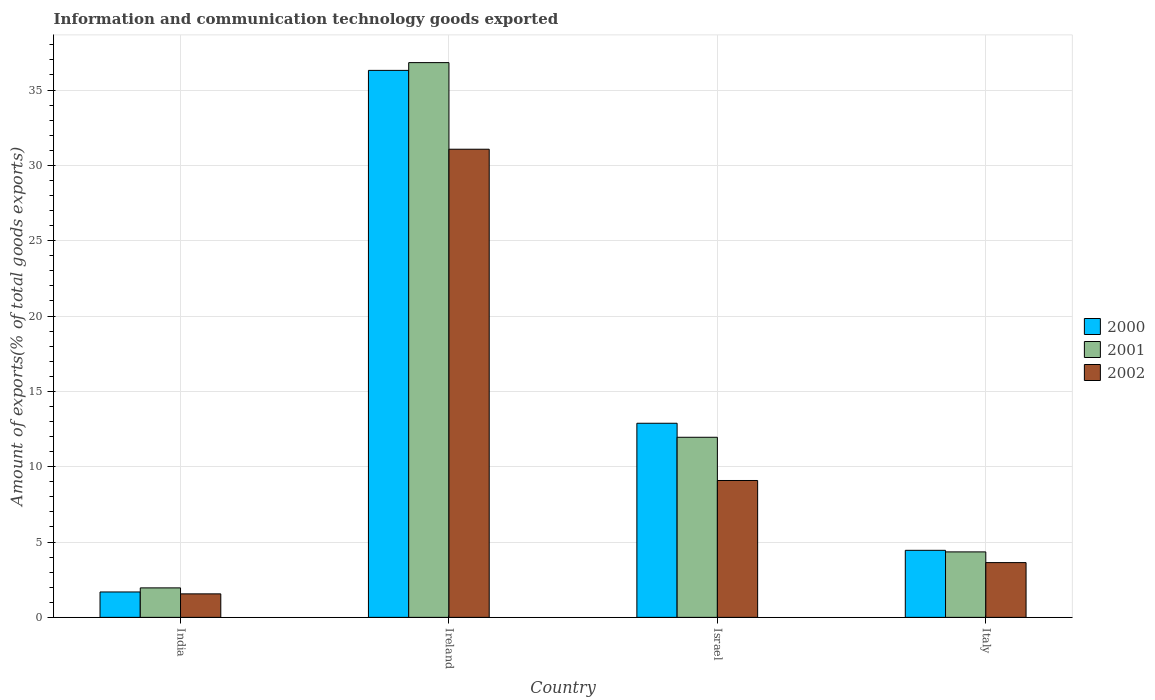Are the number of bars on each tick of the X-axis equal?
Your answer should be compact. Yes. How many bars are there on the 1st tick from the right?
Your response must be concise. 3. What is the label of the 2nd group of bars from the left?
Give a very brief answer. Ireland. In how many cases, is the number of bars for a given country not equal to the number of legend labels?
Your response must be concise. 0. What is the amount of goods exported in 2002 in Israel?
Your response must be concise. 9.08. Across all countries, what is the maximum amount of goods exported in 2002?
Ensure brevity in your answer.  31.07. Across all countries, what is the minimum amount of goods exported in 2000?
Provide a succinct answer. 1.69. In which country was the amount of goods exported in 2000 maximum?
Give a very brief answer. Ireland. What is the total amount of goods exported in 2002 in the graph?
Offer a terse response. 45.35. What is the difference between the amount of goods exported in 2001 in India and that in Israel?
Offer a terse response. -10. What is the difference between the amount of goods exported in 2002 in India and the amount of goods exported in 2001 in Israel?
Ensure brevity in your answer.  -10.39. What is the average amount of goods exported in 2002 per country?
Make the answer very short. 11.34. What is the difference between the amount of goods exported of/in 2002 and amount of goods exported of/in 2000 in Israel?
Provide a succinct answer. -3.8. In how many countries, is the amount of goods exported in 2001 greater than 28 %?
Your answer should be compact. 1. What is the ratio of the amount of goods exported in 2001 in Israel to that in Italy?
Make the answer very short. 2.75. Is the difference between the amount of goods exported in 2002 in Ireland and Israel greater than the difference between the amount of goods exported in 2000 in Ireland and Israel?
Your response must be concise. No. What is the difference between the highest and the second highest amount of goods exported in 2001?
Provide a succinct answer. -24.87. What is the difference between the highest and the lowest amount of goods exported in 2002?
Provide a short and direct response. 29.51. Is the sum of the amount of goods exported in 2002 in Ireland and Israel greater than the maximum amount of goods exported in 2000 across all countries?
Provide a succinct answer. Yes. What does the 1st bar from the right in Italy represents?
Make the answer very short. 2002. Is it the case that in every country, the sum of the amount of goods exported in 2000 and amount of goods exported in 2002 is greater than the amount of goods exported in 2001?
Make the answer very short. Yes. How many countries are there in the graph?
Ensure brevity in your answer.  4. What is the difference between two consecutive major ticks on the Y-axis?
Offer a very short reply. 5. Are the values on the major ticks of Y-axis written in scientific E-notation?
Your answer should be very brief. No. Does the graph contain grids?
Offer a very short reply. Yes. How are the legend labels stacked?
Provide a succinct answer. Vertical. What is the title of the graph?
Provide a succinct answer. Information and communication technology goods exported. What is the label or title of the X-axis?
Offer a terse response. Country. What is the label or title of the Y-axis?
Offer a terse response. Amount of exports(% of total goods exports). What is the Amount of exports(% of total goods exports) in 2000 in India?
Offer a terse response. 1.69. What is the Amount of exports(% of total goods exports) in 2001 in India?
Your answer should be very brief. 1.96. What is the Amount of exports(% of total goods exports) in 2002 in India?
Your response must be concise. 1.56. What is the Amount of exports(% of total goods exports) of 2000 in Ireland?
Ensure brevity in your answer.  36.3. What is the Amount of exports(% of total goods exports) of 2001 in Ireland?
Your response must be concise. 36.82. What is the Amount of exports(% of total goods exports) in 2002 in Ireland?
Ensure brevity in your answer.  31.07. What is the Amount of exports(% of total goods exports) in 2000 in Israel?
Provide a short and direct response. 12.88. What is the Amount of exports(% of total goods exports) of 2001 in Israel?
Offer a terse response. 11.95. What is the Amount of exports(% of total goods exports) of 2002 in Israel?
Your answer should be compact. 9.08. What is the Amount of exports(% of total goods exports) of 2000 in Italy?
Your answer should be very brief. 4.45. What is the Amount of exports(% of total goods exports) in 2001 in Italy?
Your answer should be compact. 4.34. What is the Amount of exports(% of total goods exports) in 2002 in Italy?
Ensure brevity in your answer.  3.63. Across all countries, what is the maximum Amount of exports(% of total goods exports) of 2000?
Your response must be concise. 36.3. Across all countries, what is the maximum Amount of exports(% of total goods exports) in 2001?
Your answer should be compact. 36.82. Across all countries, what is the maximum Amount of exports(% of total goods exports) of 2002?
Your response must be concise. 31.07. Across all countries, what is the minimum Amount of exports(% of total goods exports) of 2000?
Ensure brevity in your answer.  1.69. Across all countries, what is the minimum Amount of exports(% of total goods exports) in 2001?
Offer a very short reply. 1.96. Across all countries, what is the minimum Amount of exports(% of total goods exports) of 2002?
Your answer should be compact. 1.56. What is the total Amount of exports(% of total goods exports) of 2000 in the graph?
Keep it short and to the point. 55.32. What is the total Amount of exports(% of total goods exports) of 2001 in the graph?
Your answer should be compact. 55.07. What is the total Amount of exports(% of total goods exports) in 2002 in the graph?
Your answer should be compact. 45.35. What is the difference between the Amount of exports(% of total goods exports) of 2000 in India and that in Ireland?
Provide a succinct answer. -34.62. What is the difference between the Amount of exports(% of total goods exports) in 2001 in India and that in Ireland?
Keep it short and to the point. -34.86. What is the difference between the Amount of exports(% of total goods exports) in 2002 in India and that in Ireland?
Provide a succinct answer. -29.51. What is the difference between the Amount of exports(% of total goods exports) in 2000 in India and that in Israel?
Your response must be concise. -11.2. What is the difference between the Amount of exports(% of total goods exports) of 2001 in India and that in Israel?
Ensure brevity in your answer.  -10. What is the difference between the Amount of exports(% of total goods exports) of 2002 in India and that in Israel?
Keep it short and to the point. -7.52. What is the difference between the Amount of exports(% of total goods exports) in 2000 in India and that in Italy?
Your response must be concise. -2.76. What is the difference between the Amount of exports(% of total goods exports) in 2001 in India and that in Italy?
Your answer should be compact. -2.39. What is the difference between the Amount of exports(% of total goods exports) of 2002 in India and that in Italy?
Your answer should be very brief. -2.07. What is the difference between the Amount of exports(% of total goods exports) of 2000 in Ireland and that in Israel?
Give a very brief answer. 23.42. What is the difference between the Amount of exports(% of total goods exports) of 2001 in Ireland and that in Israel?
Keep it short and to the point. 24.87. What is the difference between the Amount of exports(% of total goods exports) in 2002 in Ireland and that in Israel?
Offer a very short reply. 21.99. What is the difference between the Amount of exports(% of total goods exports) in 2000 in Ireland and that in Italy?
Your answer should be very brief. 31.85. What is the difference between the Amount of exports(% of total goods exports) in 2001 in Ireland and that in Italy?
Ensure brevity in your answer.  32.47. What is the difference between the Amount of exports(% of total goods exports) in 2002 in Ireland and that in Italy?
Your answer should be compact. 27.44. What is the difference between the Amount of exports(% of total goods exports) in 2000 in Israel and that in Italy?
Provide a short and direct response. 8.43. What is the difference between the Amount of exports(% of total goods exports) in 2001 in Israel and that in Italy?
Offer a very short reply. 7.61. What is the difference between the Amount of exports(% of total goods exports) in 2002 in Israel and that in Italy?
Offer a very short reply. 5.45. What is the difference between the Amount of exports(% of total goods exports) of 2000 in India and the Amount of exports(% of total goods exports) of 2001 in Ireland?
Provide a succinct answer. -35.13. What is the difference between the Amount of exports(% of total goods exports) in 2000 in India and the Amount of exports(% of total goods exports) in 2002 in Ireland?
Your answer should be compact. -29.38. What is the difference between the Amount of exports(% of total goods exports) of 2001 in India and the Amount of exports(% of total goods exports) of 2002 in Ireland?
Your response must be concise. -29.11. What is the difference between the Amount of exports(% of total goods exports) of 2000 in India and the Amount of exports(% of total goods exports) of 2001 in Israel?
Make the answer very short. -10.27. What is the difference between the Amount of exports(% of total goods exports) of 2000 in India and the Amount of exports(% of total goods exports) of 2002 in Israel?
Give a very brief answer. -7.4. What is the difference between the Amount of exports(% of total goods exports) of 2001 in India and the Amount of exports(% of total goods exports) of 2002 in Israel?
Provide a succinct answer. -7.13. What is the difference between the Amount of exports(% of total goods exports) of 2000 in India and the Amount of exports(% of total goods exports) of 2001 in Italy?
Offer a terse response. -2.66. What is the difference between the Amount of exports(% of total goods exports) in 2000 in India and the Amount of exports(% of total goods exports) in 2002 in Italy?
Your answer should be compact. -1.95. What is the difference between the Amount of exports(% of total goods exports) of 2001 in India and the Amount of exports(% of total goods exports) of 2002 in Italy?
Offer a very short reply. -1.68. What is the difference between the Amount of exports(% of total goods exports) in 2000 in Ireland and the Amount of exports(% of total goods exports) in 2001 in Israel?
Provide a short and direct response. 24.35. What is the difference between the Amount of exports(% of total goods exports) in 2000 in Ireland and the Amount of exports(% of total goods exports) in 2002 in Israel?
Your response must be concise. 27.22. What is the difference between the Amount of exports(% of total goods exports) of 2001 in Ireland and the Amount of exports(% of total goods exports) of 2002 in Israel?
Provide a short and direct response. 27.73. What is the difference between the Amount of exports(% of total goods exports) of 2000 in Ireland and the Amount of exports(% of total goods exports) of 2001 in Italy?
Provide a succinct answer. 31.96. What is the difference between the Amount of exports(% of total goods exports) in 2000 in Ireland and the Amount of exports(% of total goods exports) in 2002 in Italy?
Make the answer very short. 32.67. What is the difference between the Amount of exports(% of total goods exports) in 2001 in Ireland and the Amount of exports(% of total goods exports) in 2002 in Italy?
Offer a very short reply. 33.18. What is the difference between the Amount of exports(% of total goods exports) of 2000 in Israel and the Amount of exports(% of total goods exports) of 2001 in Italy?
Make the answer very short. 8.54. What is the difference between the Amount of exports(% of total goods exports) of 2000 in Israel and the Amount of exports(% of total goods exports) of 2002 in Italy?
Provide a short and direct response. 9.25. What is the difference between the Amount of exports(% of total goods exports) of 2001 in Israel and the Amount of exports(% of total goods exports) of 2002 in Italy?
Make the answer very short. 8.32. What is the average Amount of exports(% of total goods exports) in 2000 per country?
Your answer should be compact. 13.83. What is the average Amount of exports(% of total goods exports) in 2001 per country?
Provide a short and direct response. 13.77. What is the average Amount of exports(% of total goods exports) in 2002 per country?
Keep it short and to the point. 11.34. What is the difference between the Amount of exports(% of total goods exports) in 2000 and Amount of exports(% of total goods exports) in 2001 in India?
Give a very brief answer. -0.27. What is the difference between the Amount of exports(% of total goods exports) of 2000 and Amount of exports(% of total goods exports) of 2002 in India?
Give a very brief answer. 0.13. What is the difference between the Amount of exports(% of total goods exports) of 2001 and Amount of exports(% of total goods exports) of 2002 in India?
Offer a terse response. 0.4. What is the difference between the Amount of exports(% of total goods exports) in 2000 and Amount of exports(% of total goods exports) in 2001 in Ireland?
Ensure brevity in your answer.  -0.52. What is the difference between the Amount of exports(% of total goods exports) in 2000 and Amount of exports(% of total goods exports) in 2002 in Ireland?
Give a very brief answer. 5.23. What is the difference between the Amount of exports(% of total goods exports) of 2001 and Amount of exports(% of total goods exports) of 2002 in Ireland?
Keep it short and to the point. 5.75. What is the difference between the Amount of exports(% of total goods exports) in 2000 and Amount of exports(% of total goods exports) in 2001 in Israel?
Provide a succinct answer. 0.93. What is the difference between the Amount of exports(% of total goods exports) of 2000 and Amount of exports(% of total goods exports) of 2002 in Israel?
Your answer should be compact. 3.8. What is the difference between the Amount of exports(% of total goods exports) in 2001 and Amount of exports(% of total goods exports) in 2002 in Israel?
Your answer should be compact. 2.87. What is the difference between the Amount of exports(% of total goods exports) in 2000 and Amount of exports(% of total goods exports) in 2001 in Italy?
Give a very brief answer. 0.1. What is the difference between the Amount of exports(% of total goods exports) of 2000 and Amount of exports(% of total goods exports) of 2002 in Italy?
Your response must be concise. 0.81. What is the difference between the Amount of exports(% of total goods exports) in 2001 and Amount of exports(% of total goods exports) in 2002 in Italy?
Your answer should be very brief. 0.71. What is the ratio of the Amount of exports(% of total goods exports) of 2000 in India to that in Ireland?
Provide a short and direct response. 0.05. What is the ratio of the Amount of exports(% of total goods exports) in 2001 in India to that in Ireland?
Provide a short and direct response. 0.05. What is the ratio of the Amount of exports(% of total goods exports) of 2002 in India to that in Ireland?
Give a very brief answer. 0.05. What is the ratio of the Amount of exports(% of total goods exports) in 2000 in India to that in Israel?
Provide a succinct answer. 0.13. What is the ratio of the Amount of exports(% of total goods exports) in 2001 in India to that in Israel?
Offer a terse response. 0.16. What is the ratio of the Amount of exports(% of total goods exports) in 2002 in India to that in Israel?
Your answer should be compact. 0.17. What is the ratio of the Amount of exports(% of total goods exports) in 2000 in India to that in Italy?
Give a very brief answer. 0.38. What is the ratio of the Amount of exports(% of total goods exports) of 2001 in India to that in Italy?
Make the answer very short. 0.45. What is the ratio of the Amount of exports(% of total goods exports) of 2002 in India to that in Italy?
Give a very brief answer. 0.43. What is the ratio of the Amount of exports(% of total goods exports) in 2000 in Ireland to that in Israel?
Provide a succinct answer. 2.82. What is the ratio of the Amount of exports(% of total goods exports) of 2001 in Ireland to that in Israel?
Your response must be concise. 3.08. What is the ratio of the Amount of exports(% of total goods exports) of 2002 in Ireland to that in Israel?
Your response must be concise. 3.42. What is the ratio of the Amount of exports(% of total goods exports) of 2000 in Ireland to that in Italy?
Ensure brevity in your answer.  8.16. What is the ratio of the Amount of exports(% of total goods exports) of 2001 in Ireland to that in Italy?
Provide a short and direct response. 8.47. What is the ratio of the Amount of exports(% of total goods exports) of 2002 in Ireland to that in Italy?
Keep it short and to the point. 8.55. What is the ratio of the Amount of exports(% of total goods exports) in 2000 in Israel to that in Italy?
Your answer should be compact. 2.9. What is the ratio of the Amount of exports(% of total goods exports) in 2001 in Israel to that in Italy?
Make the answer very short. 2.75. What is the ratio of the Amount of exports(% of total goods exports) of 2002 in Israel to that in Italy?
Give a very brief answer. 2.5. What is the difference between the highest and the second highest Amount of exports(% of total goods exports) of 2000?
Offer a very short reply. 23.42. What is the difference between the highest and the second highest Amount of exports(% of total goods exports) of 2001?
Provide a short and direct response. 24.87. What is the difference between the highest and the second highest Amount of exports(% of total goods exports) of 2002?
Your answer should be compact. 21.99. What is the difference between the highest and the lowest Amount of exports(% of total goods exports) of 2000?
Ensure brevity in your answer.  34.62. What is the difference between the highest and the lowest Amount of exports(% of total goods exports) of 2001?
Your response must be concise. 34.86. What is the difference between the highest and the lowest Amount of exports(% of total goods exports) in 2002?
Provide a short and direct response. 29.51. 